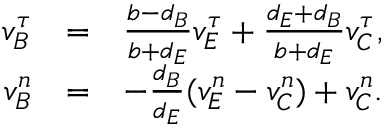<formula> <loc_0><loc_0><loc_500><loc_500>\begin{array} { r l r } { v _ { B } ^ { \tau } } & { = } & { \frac { b - d _ { B } } { b + d _ { E } } v _ { E } ^ { \tau } + \frac { d _ { E } + d _ { B } } { b + d _ { E } } v _ { C } ^ { \tau } , } \\ { v _ { B } ^ { n } } & { = } & { - \frac { d _ { B } } { d _ { E } } ( v _ { E } ^ { n } - v _ { C } ^ { n } ) + v _ { C } ^ { n } . } \end{array}</formula> 